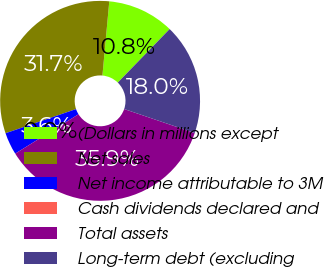Convert chart. <chart><loc_0><loc_0><loc_500><loc_500><pie_chart><fcel>(Dollars in millions except<fcel>Net sales<fcel>Net income attributable to 3M<fcel>Cash dividends declared and<fcel>Total assets<fcel>Long-term debt (excluding<nl><fcel>10.78%<fcel>31.72%<fcel>3.6%<fcel>0.0%<fcel>35.93%<fcel>17.97%<nl></chart> 